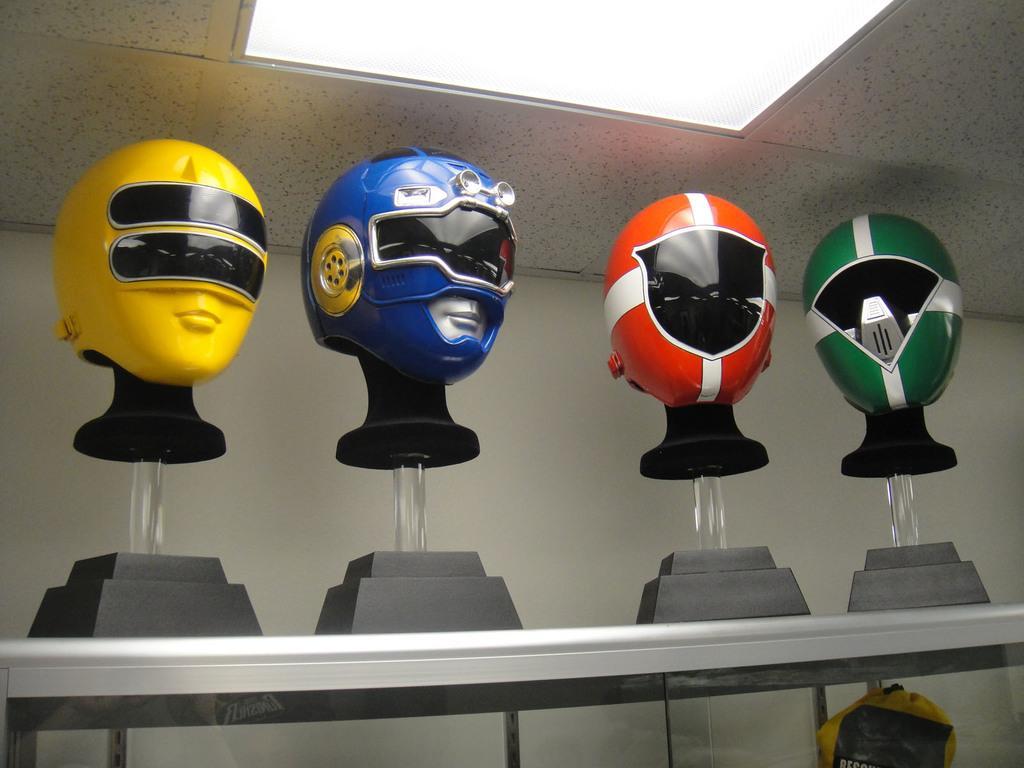Please provide a concise description of this image. In this image we can see helmets placed on the stands. At the bottom there is a table. In the background there is a wall. 